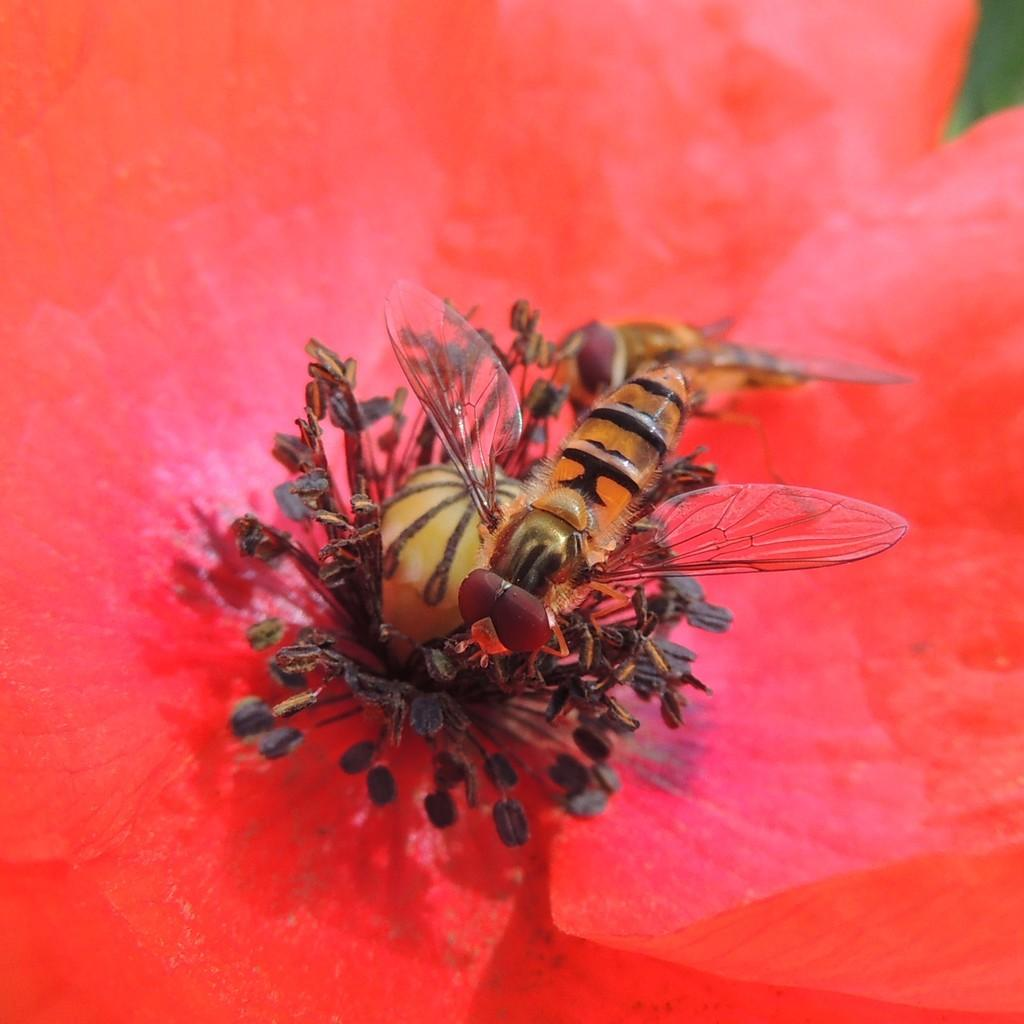What type of flower is in the image? There is a red flower in the image. Are there any other living organisms present on the flower? Yes, there are insects on the red flower. What type of vest can be seen on the frogs in the image? There are no frogs or vests present in the image; it only features a red flower with insects on it. 